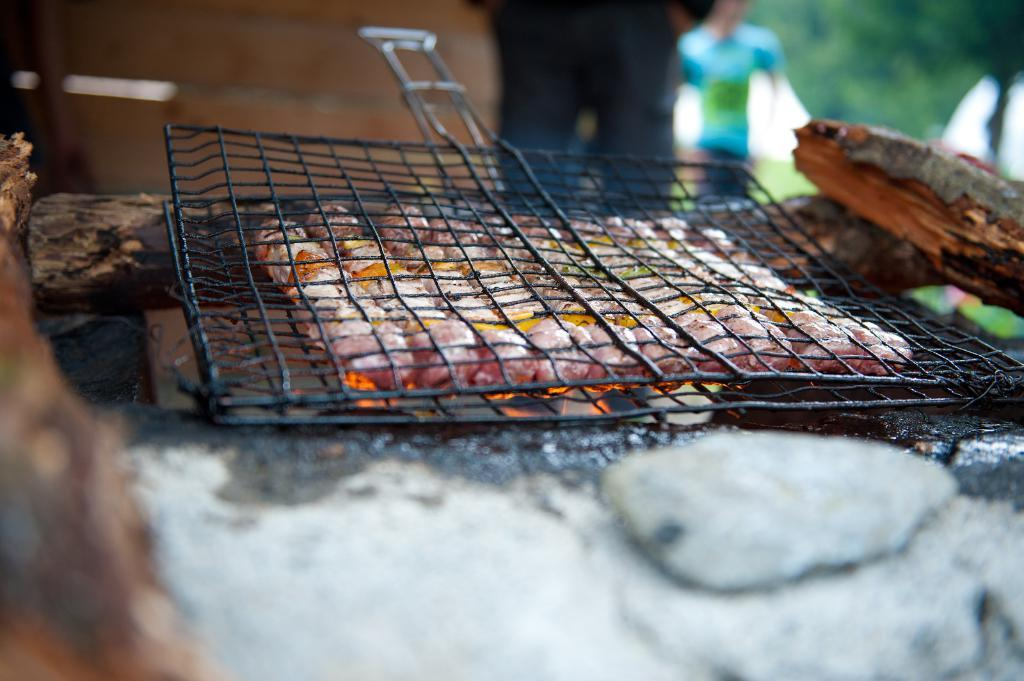What is being cooked on the grill in the image? There is meat on the grill in the image. Can you describe the setting in which the grill is located? There are persons visible in the background of the image, and there are trees in the background as well. What type of knot is being used to secure the lead in the image? There is no lead or knot present in the image; it features meat on a grill with persons and trees in the background. 